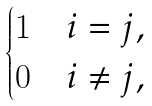<formula> <loc_0><loc_0><loc_500><loc_500>\begin{cases} 1 & i = j , \\ 0 & i \neq j , \end{cases}</formula> 